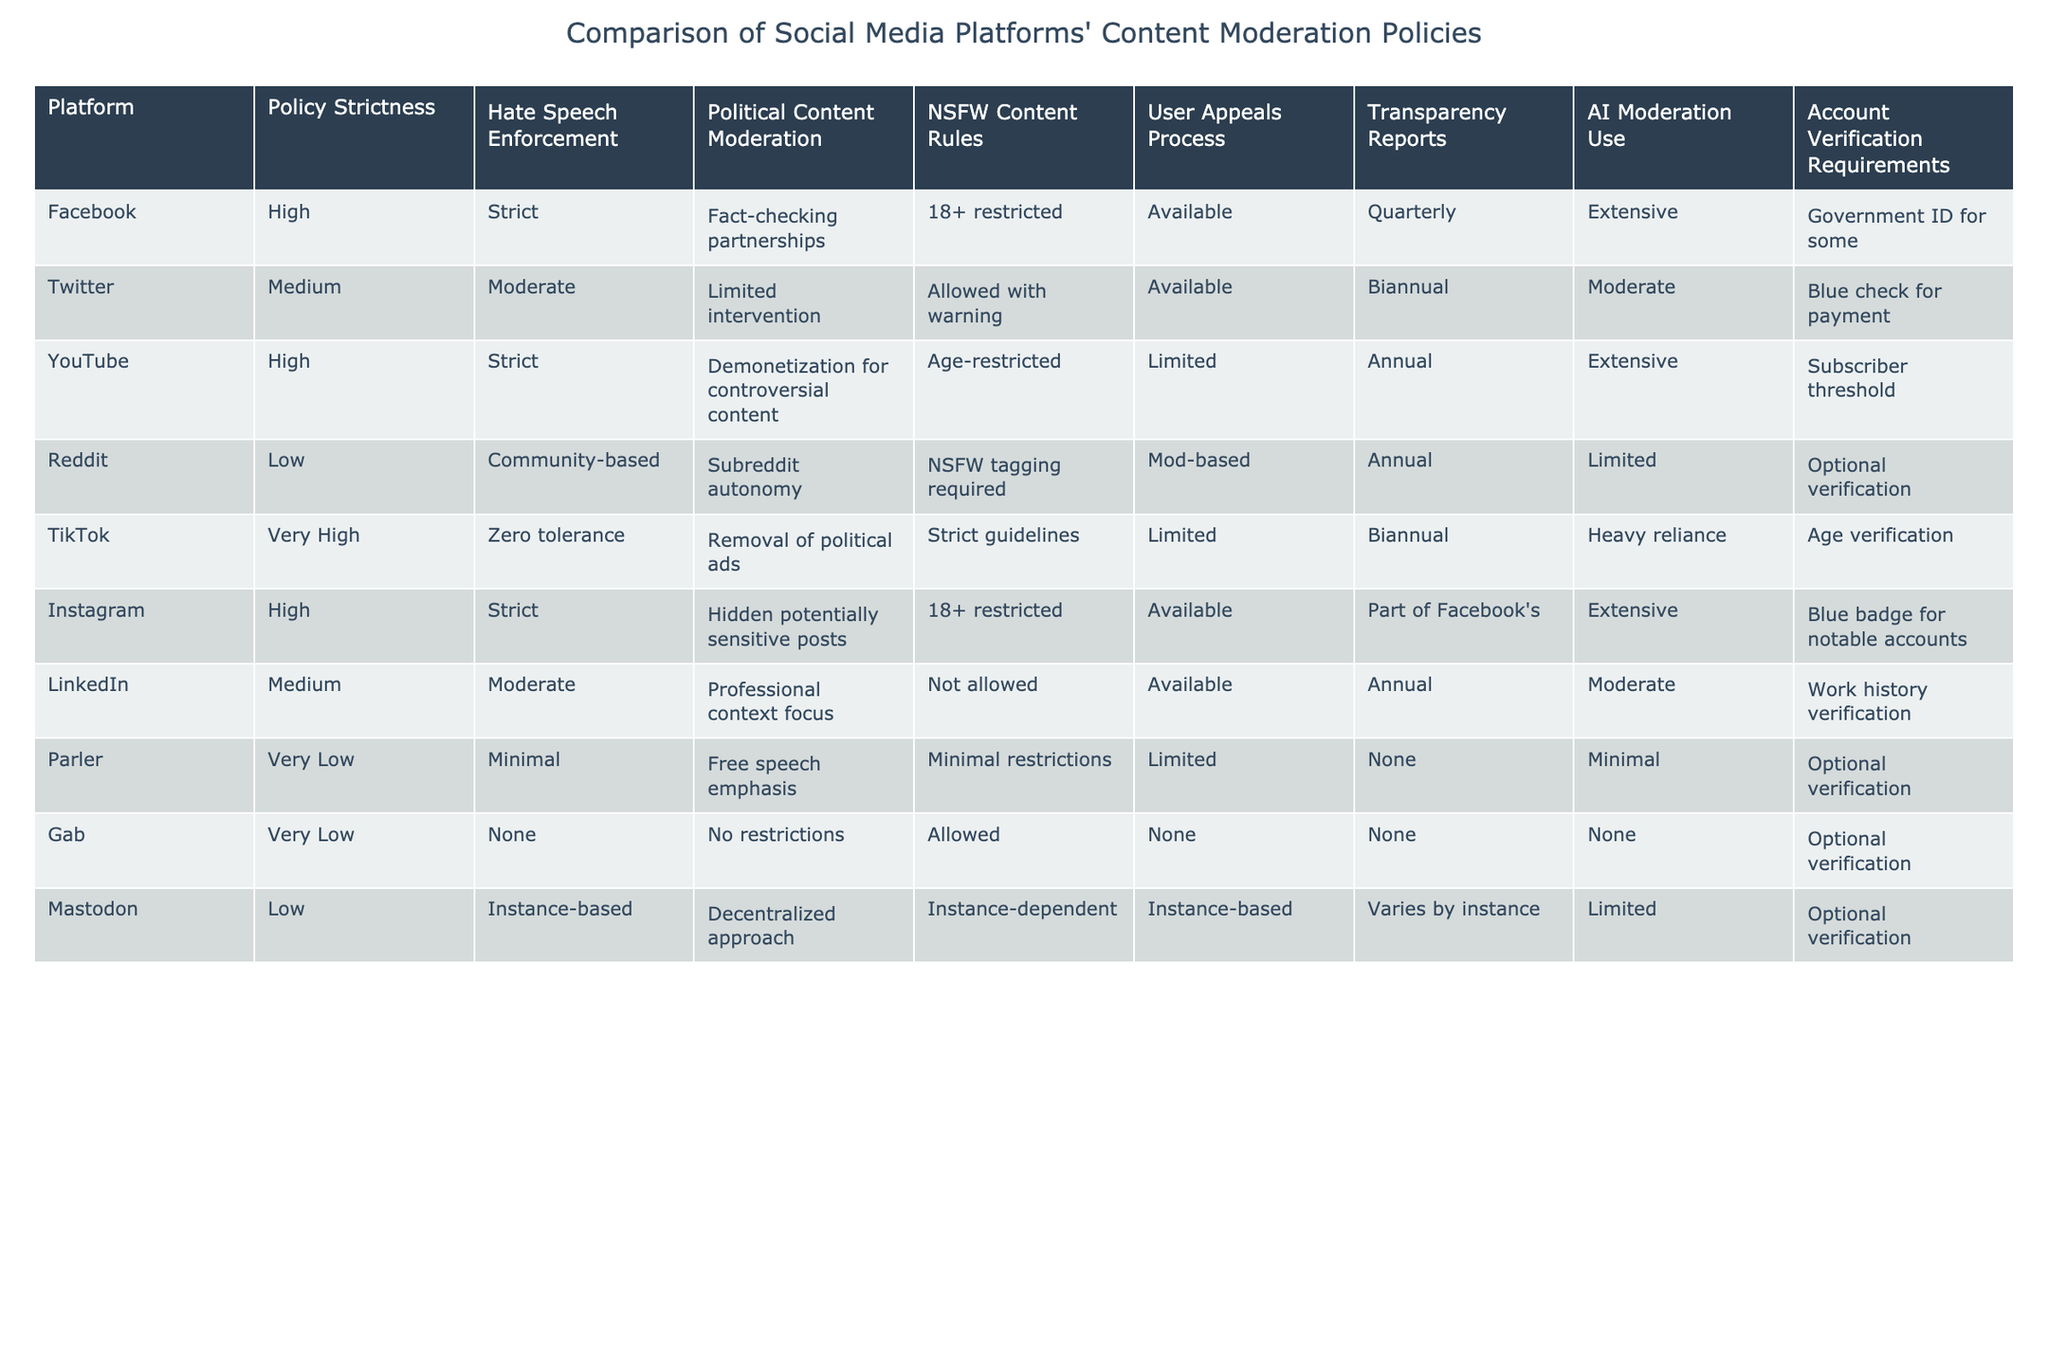What is the policy strictness level of TikTok? Looking at the table, TikTok is listed under the "Policy Strictness" column as "Very High."
Answer: Very High Which platform has the least strict enforcement of hate speech? By checking the "Hate Speech Enforcement" column, we can see that Gab has "None" listed for hate speech enforcement.
Answer: Gab Do all platforms provide a user appeals process? The table shows that not all platforms have a user appeals process; for instance, Gab and Parler do not offer one.
Answer: No Which platforms have extensive use of AI moderation? Checking the "AI Moderation Use" column reveals that Facebook and YouTube are noted for "Extensive" use of AI moderation.
Answer: Facebook and YouTube If we compare the hate speech enforcement between Reddit and Twitter, which has a stricter policy? Reddit's hate speech enforcement is listed as "Community-based" while Twitter is "Moderate." This suggests that Twitter has a stricter approach compared to Reddit.
Answer: Twitter What is the average policy strictness of platforms that have a user appeals process? The platforms with a user appeals process are Facebook, Twitter, YouTube, Instagram, and LinkedIn. Their strictness levels are High, Medium, High, High, and Medium, respectively. The average can be considered between Medium and High, leaning towards High.
Answer: High How many platforms do not allow NSFW content? By looking at the "NSFW Content Rules" column, we see that LinkedIn and TikTok do not allow NSFW content. Hence, there are two platforms.
Answer: 2 Is it true that all platforms have some form of transparency reporting? A review of the "Transparency Reports" column shows that platforms like Gab and Parler do not provide transparency reports. Hence, not all platforms offer it.
Answer: No Which platform has the most lenient account verification requirements? The "Account Verification Requirements" column indicates that Gab and Parler have "Optional verification," making them the most lenient in this category.
Answer: Gab and Parler 